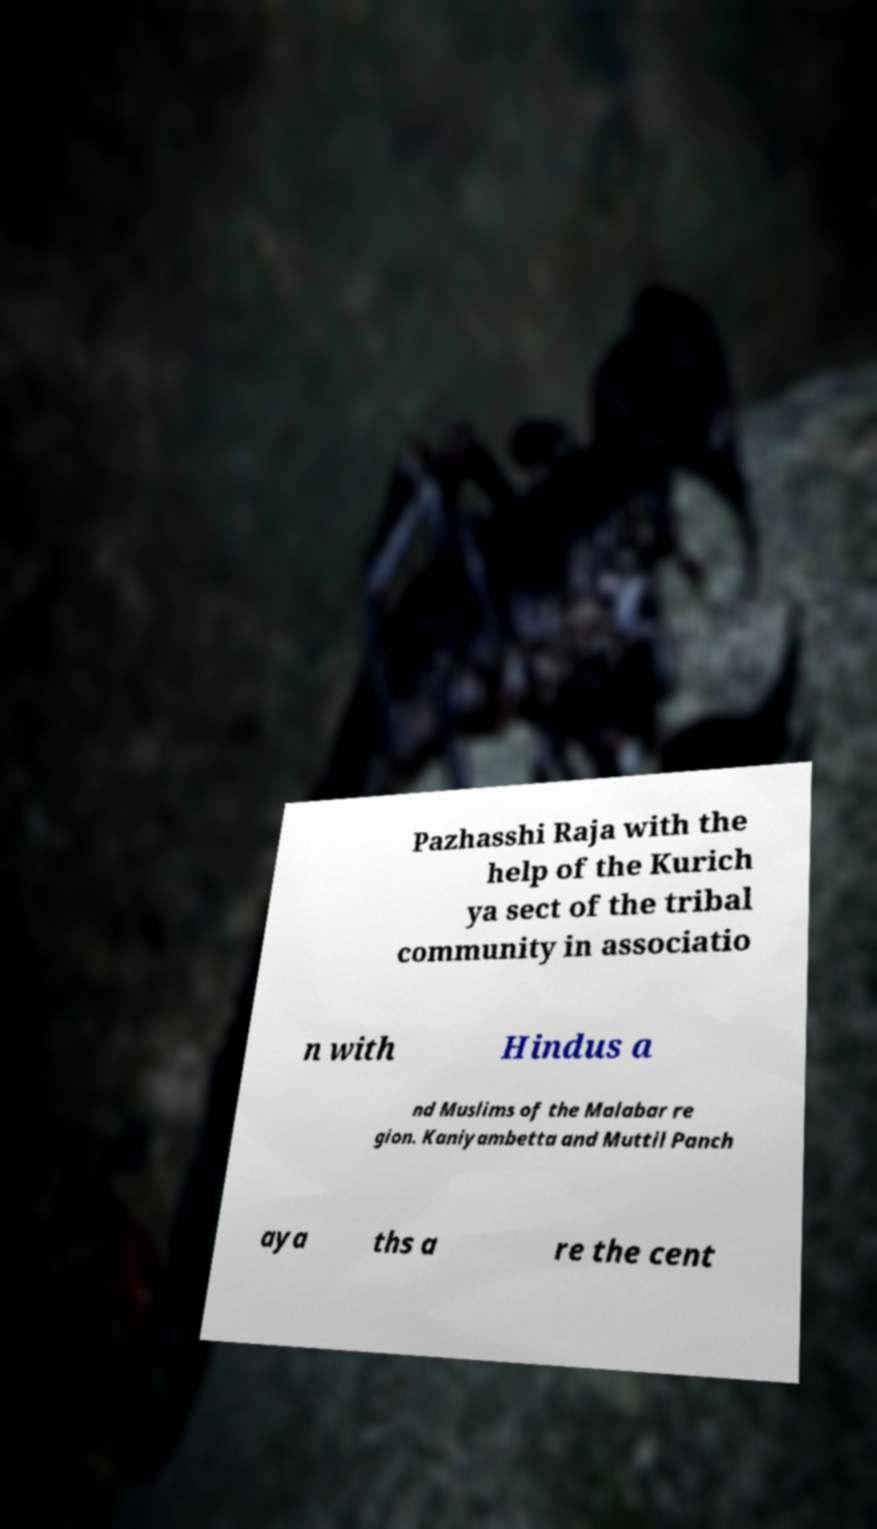What messages or text are displayed in this image? I need them in a readable, typed format. Pazhasshi Raja with the help of the Kurich ya sect of the tribal community in associatio n with Hindus a nd Muslims of the Malabar re gion. Kaniyambetta and Muttil Panch aya ths a re the cent 